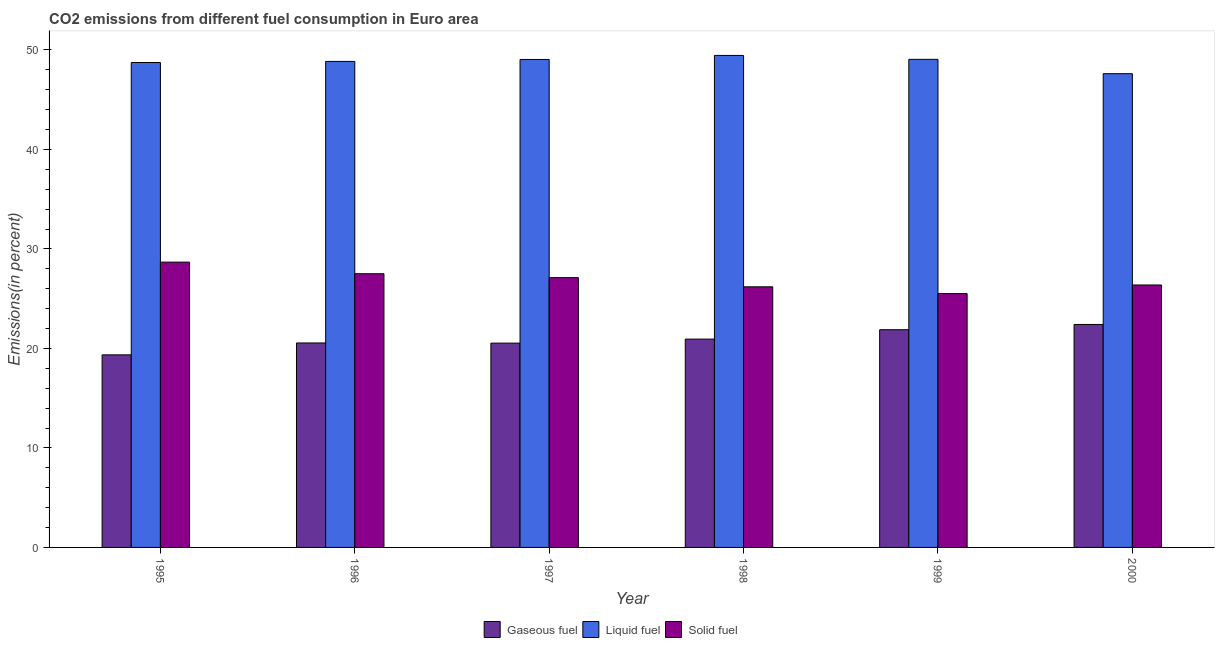How many groups of bars are there?
Your response must be concise. 6. Are the number of bars per tick equal to the number of legend labels?
Make the answer very short. Yes. Are the number of bars on each tick of the X-axis equal?
Provide a short and direct response. Yes. How many bars are there on the 3rd tick from the right?
Keep it short and to the point. 3. What is the label of the 2nd group of bars from the left?
Offer a terse response. 1996. What is the percentage of solid fuel emission in 1996?
Offer a terse response. 27.51. Across all years, what is the maximum percentage of gaseous fuel emission?
Give a very brief answer. 22.41. Across all years, what is the minimum percentage of solid fuel emission?
Keep it short and to the point. 25.51. In which year was the percentage of liquid fuel emission maximum?
Provide a succinct answer. 1998. What is the total percentage of solid fuel emission in the graph?
Your answer should be very brief. 161.36. What is the difference between the percentage of gaseous fuel emission in 1995 and that in 1998?
Your answer should be very brief. -1.58. What is the difference between the percentage of liquid fuel emission in 1999 and the percentage of solid fuel emission in 2000?
Your answer should be very brief. 1.44. What is the average percentage of liquid fuel emission per year?
Your answer should be very brief. 48.79. What is the ratio of the percentage of liquid fuel emission in 1996 to that in 1998?
Offer a terse response. 0.99. What is the difference between the highest and the second highest percentage of liquid fuel emission?
Offer a very short reply. 0.4. What is the difference between the highest and the lowest percentage of liquid fuel emission?
Ensure brevity in your answer.  1.83. Is the sum of the percentage of gaseous fuel emission in 1996 and 1998 greater than the maximum percentage of solid fuel emission across all years?
Your answer should be very brief. Yes. What does the 1st bar from the left in 1995 represents?
Your answer should be very brief. Gaseous fuel. What does the 2nd bar from the right in 1995 represents?
Your response must be concise. Liquid fuel. How many bars are there?
Ensure brevity in your answer.  18. Are all the bars in the graph horizontal?
Offer a terse response. No. How many years are there in the graph?
Provide a succinct answer. 6. Does the graph contain grids?
Offer a very short reply. No. Where does the legend appear in the graph?
Keep it short and to the point. Bottom center. How are the legend labels stacked?
Offer a terse response. Horizontal. What is the title of the graph?
Your answer should be very brief. CO2 emissions from different fuel consumption in Euro area. Does "Labor Tax" appear as one of the legend labels in the graph?
Offer a terse response. No. What is the label or title of the Y-axis?
Your response must be concise. Emissions(in percent). What is the Emissions(in percent) in Gaseous fuel in 1995?
Your response must be concise. 19.35. What is the Emissions(in percent) in Liquid fuel in 1995?
Keep it short and to the point. 48.73. What is the Emissions(in percent) of Solid fuel in 1995?
Offer a very short reply. 28.67. What is the Emissions(in percent) of Gaseous fuel in 1996?
Provide a succinct answer. 20.55. What is the Emissions(in percent) of Liquid fuel in 1996?
Provide a short and direct response. 48.84. What is the Emissions(in percent) of Solid fuel in 1996?
Provide a succinct answer. 27.51. What is the Emissions(in percent) of Gaseous fuel in 1997?
Ensure brevity in your answer.  20.53. What is the Emissions(in percent) in Liquid fuel in 1997?
Offer a terse response. 49.04. What is the Emissions(in percent) of Solid fuel in 1997?
Give a very brief answer. 27.11. What is the Emissions(in percent) of Gaseous fuel in 1998?
Give a very brief answer. 20.94. What is the Emissions(in percent) of Liquid fuel in 1998?
Give a very brief answer. 49.44. What is the Emissions(in percent) of Solid fuel in 1998?
Give a very brief answer. 26.19. What is the Emissions(in percent) of Gaseous fuel in 1999?
Provide a succinct answer. 21.88. What is the Emissions(in percent) of Liquid fuel in 1999?
Give a very brief answer. 49.05. What is the Emissions(in percent) of Solid fuel in 1999?
Keep it short and to the point. 25.51. What is the Emissions(in percent) in Gaseous fuel in 2000?
Your response must be concise. 22.41. What is the Emissions(in percent) in Liquid fuel in 2000?
Provide a succinct answer. 47.61. What is the Emissions(in percent) of Solid fuel in 2000?
Make the answer very short. 26.37. Across all years, what is the maximum Emissions(in percent) of Gaseous fuel?
Offer a very short reply. 22.41. Across all years, what is the maximum Emissions(in percent) of Liquid fuel?
Offer a very short reply. 49.44. Across all years, what is the maximum Emissions(in percent) of Solid fuel?
Ensure brevity in your answer.  28.67. Across all years, what is the minimum Emissions(in percent) in Gaseous fuel?
Make the answer very short. 19.35. Across all years, what is the minimum Emissions(in percent) of Liquid fuel?
Your answer should be compact. 47.61. Across all years, what is the minimum Emissions(in percent) in Solid fuel?
Give a very brief answer. 25.51. What is the total Emissions(in percent) of Gaseous fuel in the graph?
Give a very brief answer. 125.66. What is the total Emissions(in percent) in Liquid fuel in the graph?
Your answer should be compact. 292.72. What is the total Emissions(in percent) in Solid fuel in the graph?
Keep it short and to the point. 161.36. What is the difference between the Emissions(in percent) in Gaseous fuel in 1995 and that in 1996?
Offer a terse response. -1.2. What is the difference between the Emissions(in percent) in Liquid fuel in 1995 and that in 1996?
Provide a short and direct response. -0.11. What is the difference between the Emissions(in percent) in Solid fuel in 1995 and that in 1996?
Make the answer very short. 1.16. What is the difference between the Emissions(in percent) of Gaseous fuel in 1995 and that in 1997?
Offer a terse response. -1.18. What is the difference between the Emissions(in percent) of Liquid fuel in 1995 and that in 1997?
Make the answer very short. -0.31. What is the difference between the Emissions(in percent) in Solid fuel in 1995 and that in 1997?
Make the answer very short. 1.56. What is the difference between the Emissions(in percent) of Gaseous fuel in 1995 and that in 1998?
Ensure brevity in your answer.  -1.58. What is the difference between the Emissions(in percent) of Liquid fuel in 1995 and that in 1998?
Your answer should be compact. -0.71. What is the difference between the Emissions(in percent) in Solid fuel in 1995 and that in 1998?
Provide a succinct answer. 2.48. What is the difference between the Emissions(in percent) in Gaseous fuel in 1995 and that in 1999?
Offer a very short reply. -2.53. What is the difference between the Emissions(in percent) of Liquid fuel in 1995 and that in 1999?
Give a very brief answer. -0.32. What is the difference between the Emissions(in percent) in Solid fuel in 1995 and that in 1999?
Provide a succinct answer. 3.16. What is the difference between the Emissions(in percent) of Gaseous fuel in 1995 and that in 2000?
Offer a very short reply. -3.05. What is the difference between the Emissions(in percent) of Liquid fuel in 1995 and that in 2000?
Give a very brief answer. 1.12. What is the difference between the Emissions(in percent) of Solid fuel in 1995 and that in 2000?
Your answer should be very brief. 2.3. What is the difference between the Emissions(in percent) of Gaseous fuel in 1996 and that in 1997?
Provide a succinct answer. 0.02. What is the difference between the Emissions(in percent) in Liquid fuel in 1996 and that in 1997?
Your answer should be very brief. -0.2. What is the difference between the Emissions(in percent) in Solid fuel in 1996 and that in 1997?
Give a very brief answer. 0.4. What is the difference between the Emissions(in percent) in Gaseous fuel in 1996 and that in 1998?
Give a very brief answer. -0.39. What is the difference between the Emissions(in percent) in Liquid fuel in 1996 and that in 1998?
Offer a terse response. -0.6. What is the difference between the Emissions(in percent) of Solid fuel in 1996 and that in 1998?
Keep it short and to the point. 1.32. What is the difference between the Emissions(in percent) in Gaseous fuel in 1996 and that in 1999?
Provide a short and direct response. -1.33. What is the difference between the Emissions(in percent) in Liquid fuel in 1996 and that in 1999?
Offer a very short reply. -0.21. What is the difference between the Emissions(in percent) in Solid fuel in 1996 and that in 1999?
Your answer should be compact. 2. What is the difference between the Emissions(in percent) in Gaseous fuel in 1996 and that in 2000?
Give a very brief answer. -1.86. What is the difference between the Emissions(in percent) in Liquid fuel in 1996 and that in 2000?
Your answer should be very brief. 1.23. What is the difference between the Emissions(in percent) in Solid fuel in 1996 and that in 2000?
Provide a succinct answer. 1.13. What is the difference between the Emissions(in percent) in Gaseous fuel in 1997 and that in 1998?
Your response must be concise. -0.4. What is the difference between the Emissions(in percent) in Liquid fuel in 1997 and that in 1998?
Make the answer very short. -0.41. What is the difference between the Emissions(in percent) in Solid fuel in 1997 and that in 1998?
Your answer should be very brief. 0.92. What is the difference between the Emissions(in percent) of Gaseous fuel in 1997 and that in 1999?
Your answer should be compact. -1.35. What is the difference between the Emissions(in percent) of Liquid fuel in 1997 and that in 1999?
Keep it short and to the point. -0.01. What is the difference between the Emissions(in percent) in Solid fuel in 1997 and that in 1999?
Provide a short and direct response. 1.6. What is the difference between the Emissions(in percent) of Gaseous fuel in 1997 and that in 2000?
Ensure brevity in your answer.  -1.87. What is the difference between the Emissions(in percent) of Liquid fuel in 1997 and that in 2000?
Give a very brief answer. 1.43. What is the difference between the Emissions(in percent) of Solid fuel in 1997 and that in 2000?
Make the answer very short. 0.74. What is the difference between the Emissions(in percent) in Gaseous fuel in 1998 and that in 1999?
Ensure brevity in your answer.  -0.94. What is the difference between the Emissions(in percent) in Liquid fuel in 1998 and that in 1999?
Your response must be concise. 0.4. What is the difference between the Emissions(in percent) in Solid fuel in 1998 and that in 1999?
Ensure brevity in your answer.  0.68. What is the difference between the Emissions(in percent) in Gaseous fuel in 1998 and that in 2000?
Make the answer very short. -1.47. What is the difference between the Emissions(in percent) in Liquid fuel in 1998 and that in 2000?
Offer a very short reply. 1.83. What is the difference between the Emissions(in percent) of Solid fuel in 1998 and that in 2000?
Ensure brevity in your answer.  -0.18. What is the difference between the Emissions(in percent) in Gaseous fuel in 1999 and that in 2000?
Keep it short and to the point. -0.53. What is the difference between the Emissions(in percent) in Liquid fuel in 1999 and that in 2000?
Your answer should be compact. 1.44. What is the difference between the Emissions(in percent) of Solid fuel in 1999 and that in 2000?
Your answer should be very brief. -0.87. What is the difference between the Emissions(in percent) of Gaseous fuel in 1995 and the Emissions(in percent) of Liquid fuel in 1996?
Provide a short and direct response. -29.49. What is the difference between the Emissions(in percent) in Gaseous fuel in 1995 and the Emissions(in percent) in Solid fuel in 1996?
Give a very brief answer. -8.15. What is the difference between the Emissions(in percent) in Liquid fuel in 1995 and the Emissions(in percent) in Solid fuel in 1996?
Your answer should be very brief. 21.23. What is the difference between the Emissions(in percent) in Gaseous fuel in 1995 and the Emissions(in percent) in Liquid fuel in 1997?
Provide a succinct answer. -29.69. What is the difference between the Emissions(in percent) of Gaseous fuel in 1995 and the Emissions(in percent) of Solid fuel in 1997?
Offer a terse response. -7.76. What is the difference between the Emissions(in percent) of Liquid fuel in 1995 and the Emissions(in percent) of Solid fuel in 1997?
Ensure brevity in your answer.  21.62. What is the difference between the Emissions(in percent) of Gaseous fuel in 1995 and the Emissions(in percent) of Liquid fuel in 1998?
Your answer should be very brief. -30.09. What is the difference between the Emissions(in percent) in Gaseous fuel in 1995 and the Emissions(in percent) in Solid fuel in 1998?
Offer a terse response. -6.84. What is the difference between the Emissions(in percent) of Liquid fuel in 1995 and the Emissions(in percent) of Solid fuel in 1998?
Ensure brevity in your answer.  22.54. What is the difference between the Emissions(in percent) of Gaseous fuel in 1995 and the Emissions(in percent) of Liquid fuel in 1999?
Offer a very short reply. -29.7. What is the difference between the Emissions(in percent) of Gaseous fuel in 1995 and the Emissions(in percent) of Solid fuel in 1999?
Make the answer very short. -6.16. What is the difference between the Emissions(in percent) in Liquid fuel in 1995 and the Emissions(in percent) in Solid fuel in 1999?
Your response must be concise. 23.22. What is the difference between the Emissions(in percent) of Gaseous fuel in 1995 and the Emissions(in percent) of Liquid fuel in 2000?
Make the answer very short. -28.26. What is the difference between the Emissions(in percent) of Gaseous fuel in 1995 and the Emissions(in percent) of Solid fuel in 2000?
Your answer should be compact. -7.02. What is the difference between the Emissions(in percent) of Liquid fuel in 1995 and the Emissions(in percent) of Solid fuel in 2000?
Your response must be concise. 22.36. What is the difference between the Emissions(in percent) in Gaseous fuel in 1996 and the Emissions(in percent) in Liquid fuel in 1997?
Provide a succinct answer. -28.49. What is the difference between the Emissions(in percent) of Gaseous fuel in 1996 and the Emissions(in percent) of Solid fuel in 1997?
Your answer should be very brief. -6.56. What is the difference between the Emissions(in percent) of Liquid fuel in 1996 and the Emissions(in percent) of Solid fuel in 1997?
Provide a short and direct response. 21.73. What is the difference between the Emissions(in percent) of Gaseous fuel in 1996 and the Emissions(in percent) of Liquid fuel in 1998?
Your answer should be compact. -28.9. What is the difference between the Emissions(in percent) in Gaseous fuel in 1996 and the Emissions(in percent) in Solid fuel in 1998?
Ensure brevity in your answer.  -5.64. What is the difference between the Emissions(in percent) in Liquid fuel in 1996 and the Emissions(in percent) in Solid fuel in 1998?
Provide a short and direct response. 22.65. What is the difference between the Emissions(in percent) in Gaseous fuel in 1996 and the Emissions(in percent) in Liquid fuel in 1999?
Offer a very short reply. -28.5. What is the difference between the Emissions(in percent) of Gaseous fuel in 1996 and the Emissions(in percent) of Solid fuel in 1999?
Offer a terse response. -4.96. What is the difference between the Emissions(in percent) of Liquid fuel in 1996 and the Emissions(in percent) of Solid fuel in 1999?
Provide a succinct answer. 23.33. What is the difference between the Emissions(in percent) of Gaseous fuel in 1996 and the Emissions(in percent) of Liquid fuel in 2000?
Provide a succinct answer. -27.06. What is the difference between the Emissions(in percent) in Gaseous fuel in 1996 and the Emissions(in percent) in Solid fuel in 2000?
Offer a very short reply. -5.83. What is the difference between the Emissions(in percent) in Liquid fuel in 1996 and the Emissions(in percent) in Solid fuel in 2000?
Make the answer very short. 22.47. What is the difference between the Emissions(in percent) in Gaseous fuel in 1997 and the Emissions(in percent) in Liquid fuel in 1998?
Provide a short and direct response. -28.91. What is the difference between the Emissions(in percent) of Gaseous fuel in 1997 and the Emissions(in percent) of Solid fuel in 1998?
Give a very brief answer. -5.66. What is the difference between the Emissions(in percent) of Liquid fuel in 1997 and the Emissions(in percent) of Solid fuel in 1998?
Your response must be concise. 22.85. What is the difference between the Emissions(in percent) of Gaseous fuel in 1997 and the Emissions(in percent) of Liquid fuel in 1999?
Your response must be concise. -28.52. What is the difference between the Emissions(in percent) in Gaseous fuel in 1997 and the Emissions(in percent) in Solid fuel in 1999?
Provide a short and direct response. -4.98. What is the difference between the Emissions(in percent) in Liquid fuel in 1997 and the Emissions(in percent) in Solid fuel in 1999?
Offer a very short reply. 23.53. What is the difference between the Emissions(in percent) of Gaseous fuel in 1997 and the Emissions(in percent) of Liquid fuel in 2000?
Offer a very short reply. -27.08. What is the difference between the Emissions(in percent) in Gaseous fuel in 1997 and the Emissions(in percent) in Solid fuel in 2000?
Your response must be concise. -5.84. What is the difference between the Emissions(in percent) in Liquid fuel in 1997 and the Emissions(in percent) in Solid fuel in 2000?
Keep it short and to the point. 22.66. What is the difference between the Emissions(in percent) in Gaseous fuel in 1998 and the Emissions(in percent) in Liquid fuel in 1999?
Give a very brief answer. -28.11. What is the difference between the Emissions(in percent) of Gaseous fuel in 1998 and the Emissions(in percent) of Solid fuel in 1999?
Make the answer very short. -4.57. What is the difference between the Emissions(in percent) in Liquid fuel in 1998 and the Emissions(in percent) in Solid fuel in 1999?
Offer a very short reply. 23.94. What is the difference between the Emissions(in percent) of Gaseous fuel in 1998 and the Emissions(in percent) of Liquid fuel in 2000?
Provide a short and direct response. -26.67. What is the difference between the Emissions(in percent) in Gaseous fuel in 1998 and the Emissions(in percent) in Solid fuel in 2000?
Your response must be concise. -5.44. What is the difference between the Emissions(in percent) in Liquid fuel in 1998 and the Emissions(in percent) in Solid fuel in 2000?
Your answer should be very brief. 23.07. What is the difference between the Emissions(in percent) in Gaseous fuel in 1999 and the Emissions(in percent) in Liquid fuel in 2000?
Your response must be concise. -25.73. What is the difference between the Emissions(in percent) of Gaseous fuel in 1999 and the Emissions(in percent) of Solid fuel in 2000?
Keep it short and to the point. -4.5. What is the difference between the Emissions(in percent) in Liquid fuel in 1999 and the Emissions(in percent) in Solid fuel in 2000?
Offer a very short reply. 22.67. What is the average Emissions(in percent) of Gaseous fuel per year?
Provide a short and direct response. 20.94. What is the average Emissions(in percent) of Liquid fuel per year?
Provide a short and direct response. 48.79. What is the average Emissions(in percent) in Solid fuel per year?
Provide a succinct answer. 26.89. In the year 1995, what is the difference between the Emissions(in percent) in Gaseous fuel and Emissions(in percent) in Liquid fuel?
Give a very brief answer. -29.38. In the year 1995, what is the difference between the Emissions(in percent) of Gaseous fuel and Emissions(in percent) of Solid fuel?
Your response must be concise. -9.32. In the year 1995, what is the difference between the Emissions(in percent) of Liquid fuel and Emissions(in percent) of Solid fuel?
Provide a succinct answer. 20.06. In the year 1996, what is the difference between the Emissions(in percent) of Gaseous fuel and Emissions(in percent) of Liquid fuel?
Your answer should be very brief. -28.29. In the year 1996, what is the difference between the Emissions(in percent) of Gaseous fuel and Emissions(in percent) of Solid fuel?
Your response must be concise. -6.96. In the year 1996, what is the difference between the Emissions(in percent) in Liquid fuel and Emissions(in percent) in Solid fuel?
Offer a terse response. 21.34. In the year 1997, what is the difference between the Emissions(in percent) in Gaseous fuel and Emissions(in percent) in Liquid fuel?
Make the answer very short. -28.51. In the year 1997, what is the difference between the Emissions(in percent) in Gaseous fuel and Emissions(in percent) in Solid fuel?
Provide a short and direct response. -6.58. In the year 1997, what is the difference between the Emissions(in percent) in Liquid fuel and Emissions(in percent) in Solid fuel?
Offer a very short reply. 21.93. In the year 1998, what is the difference between the Emissions(in percent) of Gaseous fuel and Emissions(in percent) of Liquid fuel?
Ensure brevity in your answer.  -28.51. In the year 1998, what is the difference between the Emissions(in percent) in Gaseous fuel and Emissions(in percent) in Solid fuel?
Your answer should be very brief. -5.25. In the year 1998, what is the difference between the Emissions(in percent) of Liquid fuel and Emissions(in percent) of Solid fuel?
Offer a terse response. 23.25. In the year 1999, what is the difference between the Emissions(in percent) of Gaseous fuel and Emissions(in percent) of Liquid fuel?
Ensure brevity in your answer.  -27.17. In the year 1999, what is the difference between the Emissions(in percent) of Gaseous fuel and Emissions(in percent) of Solid fuel?
Provide a short and direct response. -3.63. In the year 1999, what is the difference between the Emissions(in percent) of Liquid fuel and Emissions(in percent) of Solid fuel?
Offer a terse response. 23.54. In the year 2000, what is the difference between the Emissions(in percent) of Gaseous fuel and Emissions(in percent) of Liquid fuel?
Offer a very short reply. -25.2. In the year 2000, what is the difference between the Emissions(in percent) in Gaseous fuel and Emissions(in percent) in Solid fuel?
Your response must be concise. -3.97. In the year 2000, what is the difference between the Emissions(in percent) in Liquid fuel and Emissions(in percent) in Solid fuel?
Provide a succinct answer. 21.24. What is the ratio of the Emissions(in percent) of Gaseous fuel in 1995 to that in 1996?
Give a very brief answer. 0.94. What is the ratio of the Emissions(in percent) in Solid fuel in 1995 to that in 1996?
Make the answer very short. 1.04. What is the ratio of the Emissions(in percent) of Gaseous fuel in 1995 to that in 1997?
Your answer should be compact. 0.94. What is the ratio of the Emissions(in percent) in Liquid fuel in 1995 to that in 1997?
Your response must be concise. 0.99. What is the ratio of the Emissions(in percent) of Solid fuel in 1995 to that in 1997?
Offer a terse response. 1.06. What is the ratio of the Emissions(in percent) in Gaseous fuel in 1995 to that in 1998?
Keep it short and to the point. 0.92. What is the ratio of the Emissions(in percent) in Liquid fuel in 1995 to that in 1998?
Ensure brevity in your answer.  0.99. What is the ratio of the Emissions(in percent) in Solid fuel in 1995 to that in 1998?
Offer a very short reply. 1.09. What is the ratio of the Emissions(in percent) in Gaseous fuel in 1995 to that in 1999?
Give a very brief answer. 0.88. What is the ratio of the Emissions(in percent) in Liquid fuel in 1995 to that in 1999?
Keep it short and to the point. 0.99. What is the ratio of the Emissions(in percent) of Solid fuel in 1995 to that in 1999?
Your answer should be compact. 1.12. What is the ratio of the Emissions(in percent) in Gaseous fuel in 1995 to that in 2000?
Your response must be concise. 0.86. What is the ratio of the Emissions(in percent) of Liquid fuel in 1995 to that in 2000?
Your answer should be very brief. 1.02. What is the ratio of the Emissions(in percent) in Solid fuel in 1995 to that in 2000?
Offer a very short reply. 1.09. What is the ratio of the Emissions(in percent) in Solid fuel in 1996 to that in 1997?
Offer a very short reply. 1.01. What is the ratio of the Emissions(in percent) of Gaseous fuel in 1996 to that in 1998?
Offer a very short reply. 0.98. What is the ratio of the Emissions(in percent) in Liquid fuel in 1996 to that in 1998?
Give a very brief answer. 0.99. What is the ratio of the Emissions(in percent) of Solid fuel in 1996 to that in 1998?
Offer a very short reply. 1.05. What is the ratio of the Emissions(in percent) of Gaseous fuel in 1996 to that in 1999?
Your answer should be compact. 0.94. What is the ratio of the Emissions(in percent) of Solid fuel in 1996 to that in 1999?
Make the answer very short. 1.08. What is the ratio of the Emissions(in percent) in Gaseous fuel in 1996 to that in 2000?
Keep it short and to the point. 0.92. What is the ratio of the Emissions(in percent) of Liquid fuel in 1996 to that in 2000?
Provide a short and direct response. 1.03. What is the ratio of the Emissions(in percent) of Solid fuel in 1996 to that in 2000?
Make the answer very short. 1.04. What is the ratio of the Emissions(in percent) in Gaseous fuel in 1997 to that in 1998?
Provide a short and direct response. 0.98. What is the ratio of the Emissions(in percent) of Solid fuel in 1997 to that in 1998?
Your answer should be compact. 1.04. What is the ratio of the Emissions(in percent) in Gaseous fuel in 1997 to that in 1999?
Ensure brevity in your answer.  0.94. What is the ratio of the Emissions(in percent) of Liquid fuel in 1997 to that in 1999?
Your response must be concise. 1. What is the ratio of the Emissions(in percent) in Solid fuel in 1997 to that in 1999?
Provide a succinct answer. 1.06. What is the ratio of the Emissions(in percent) of Gaseous fuel in 1997 to that in 2000?
Make the answer very short. 0.92. What is the ratio of the Emissions(in percent) of Liquid fuel in 1997 to that in 2000?
Your answer should be very brief. 1.03. What is the ratio of the Emissions(in percent) of Solid fuel in 1997 to that in 2000?
Keep it short and to the point. 1.03. What is the ratio of the Emissions(in percent) of Gaseous fuel in 1998 to that in 1999?
Offer a very short reply. 0.96. What is the ratio of the Emissions(in percent) of Solid fuel in 1998 to that in 1999?
Offer a terse response. 1.03. What is the ratio of the Emissions(in percent) in Gaseous fuel in 1998 to that in 2000?
Give a very brief answer. 0.93. What is the ratio of the Emissions(in percent) in Liquid fuel in 1998 to that in 2000?
Your response must be concise. 1.04. What is the ratio of the Emissions(in percent) in Solid fuel in 1998 to that in 2000?
Offer a very short reply. 0.99. What is the ratio of the Emissions(in percent) in Gaseous fuel in 1999 to that in 2000?
Ensure brevity in your answer.  0.98. What is the ratio of the Emissions(in percent) in Liquid fuel in 1999 to that in 2000?
Give a very brief answer. 1.03. What is the ratio of the Emissions(in percent) of Solid fuel in 1999 to that in 2000?
Your answer should be compact. 0.97. What is the difference between the highest and the second highest Emissions(in percent) of Gaseous fuel?
Give a very brief answer. 0.53. What is the difference between the highest and the second highest Emissions(in percent) of Liquid fuel?
Make the answer very short. 0.4. What is the difference between the highest and the second highest Emissions(in percent) in Solid fuel?
Ensure brevity in your answer.  1.16. What is the difference between the highest and the lowest Emissions(in percent) in Gaseous fuel?
Your answer should be compact. 3.05. What is the difference between the highest and the lowest Emissions(in percent) of Liquid fuel?
Your answer should be very brief. 1.83. What is the difference between the highest and the lowest Emissions(in percent) of Solid fuel?
Your response must be concise. 3.16. 